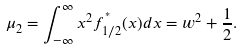<formula> <loc_0><loc_0><loc_500><loc_500>\mu _ { 2 } = \int _ { - \infty } ^ { \infty } x ^ { 2 } f _ { 1 / 2 } ^ { ^ { * } } ( x ) d x = w ^ { 2 } + \frac { 1 } { 2 } .</formula> 